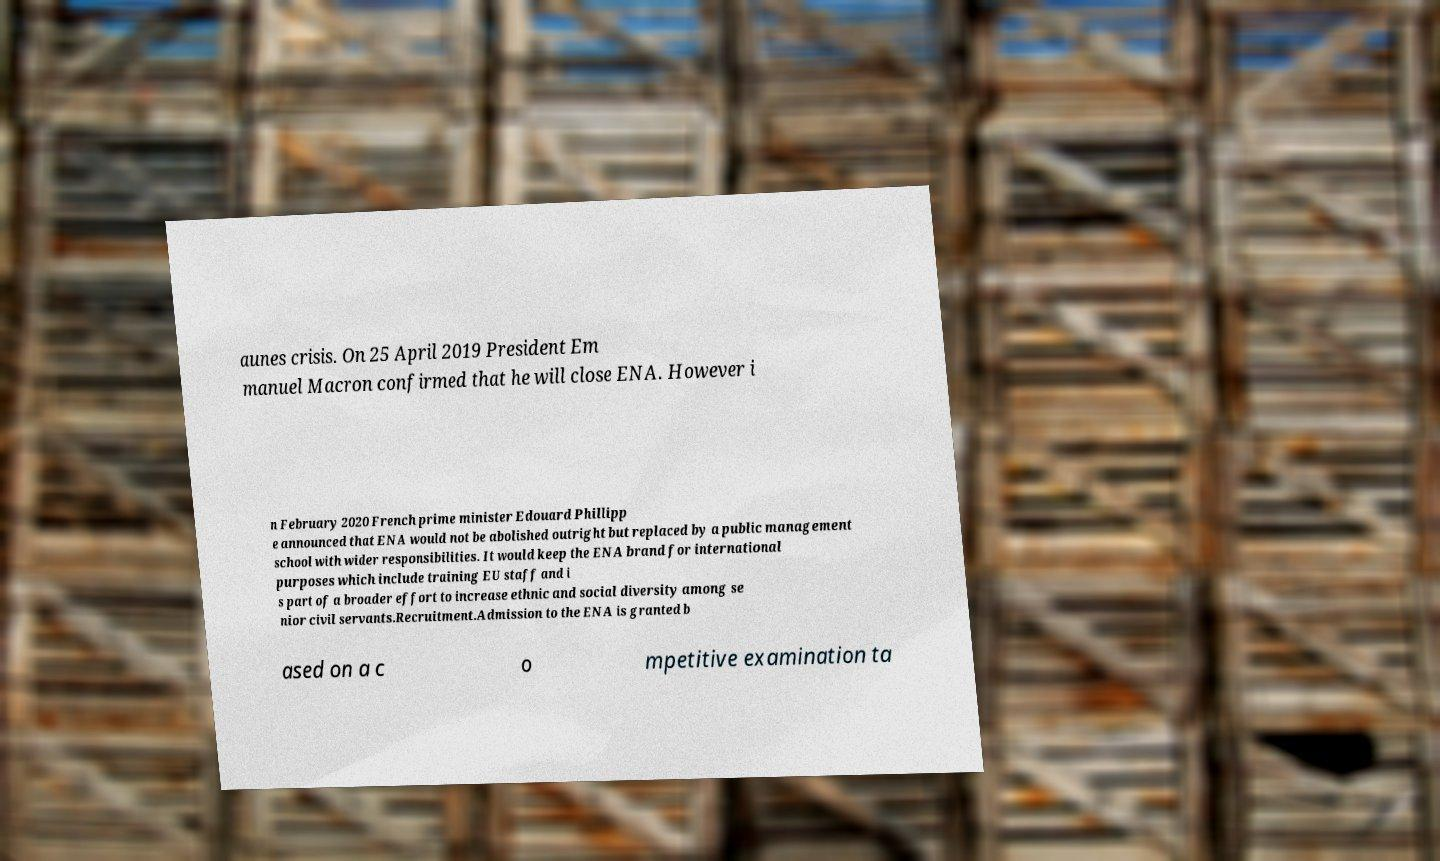Can you read and provide the text displayed in the image?This photo seems to have some interesting text. Can you extract and type it out for me? aunes crisis. On 25 April 2019 President Em manuel Macron confirmed that he will close ENA. However i n February 2020 French prime minister Edouard Phillipp e announced that ENA would not be abolished outright but replaced by a public management school with wider responsibilities. It would keep the ENA brand for international purposes which include training EU staff and i s part of a broader effort to increase ethnic and social diversity among se nior civil servants.Recruitment.Admission to the ENA is granted b ased on a c o mpetitive examination ta 